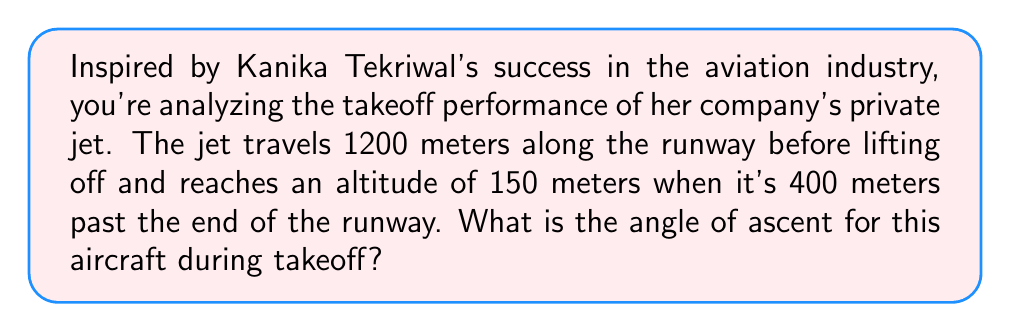Can you answer this question? Let's approach this step-by-step:

1) First, we need to visualize the problem. The plane's path forms a right triangle with the ground.

[asy]
import geometry;

pair A=(0,0), B=(1600,0), C=(1600,150);
draw(A--B--C--A);
label("1600 m", (800,0), S);
label("150 m", (1600,75), E);
label("θ", (0,0), NW);
draw(A--(0,20)--(20,20)--(20,0));
[/asy]

2) We know:
   - The total horizontal distance is 1200 m (runway) + 400 m = 1600 m
   - The vertical height is 150 m

3) We can use the tangent function to find the angle. In a right triangle:

   $$ \tan(\theta) = \frac{\text{opposite}}{\text{adjacent}} = \frac{\text{height}}{\text{distance}} $$

4) Plugging in our values:

   $$ \tan(\theta) = \frac{150}{1600} $$

5) To find θ, we need to use the inverse tangent (arctan or $\tan^{-1}$):

   $$ \theta = \tan^{-1}\left(\frac{150}{1600}\right) $$

6) Using a calculator:

   $$ \theta \approx 5.35^\circ $$
Answer: $5.35^\circ$ 